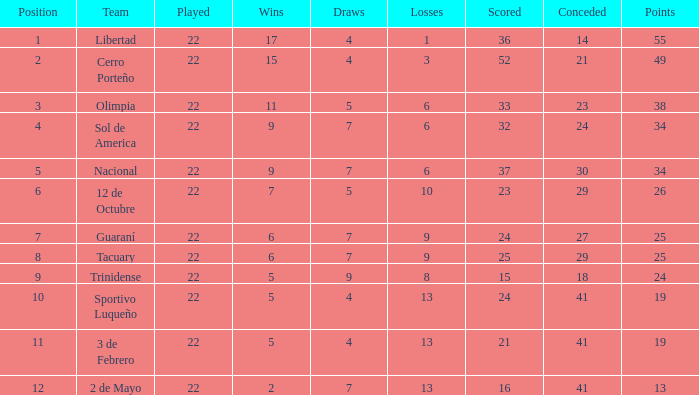What is the fewest wins that has fewer than 23 goals scored, team of 2 de Mayo, and fewer than 7 draws? None. 